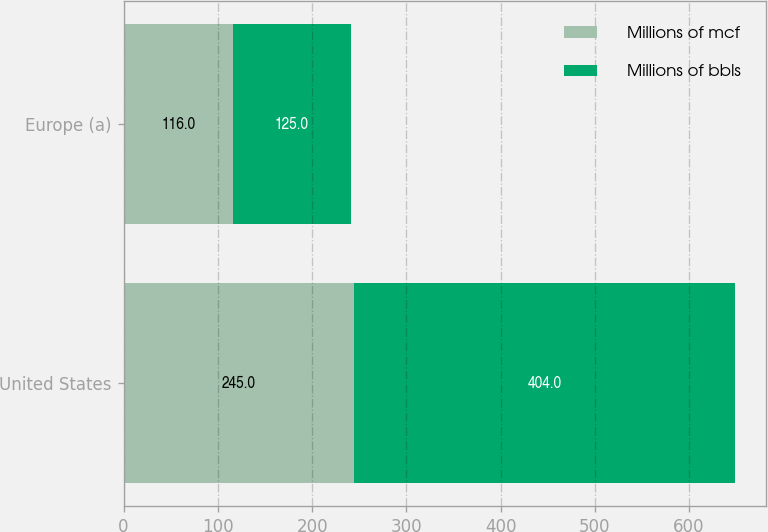Convert chart. <chart><loc_0><loc_0><loc_500><loc_500><stacked_bar_chart><ecel><fcel>United States<fcel>Europe (a)<nl><fcel>Millions of mcf<fcel>245<fcel>116<nl><fcel>Millions of bbls<fcel>404<fcel>125<nl></chart> 